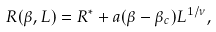<formula> <loc_0><loc_0><loc_500><loc_500>R ( \beta , L ) = R ^ { * } + a ( \beta - \beta _ { c } ) L ^ { 1 / \nu } ,</formula> 